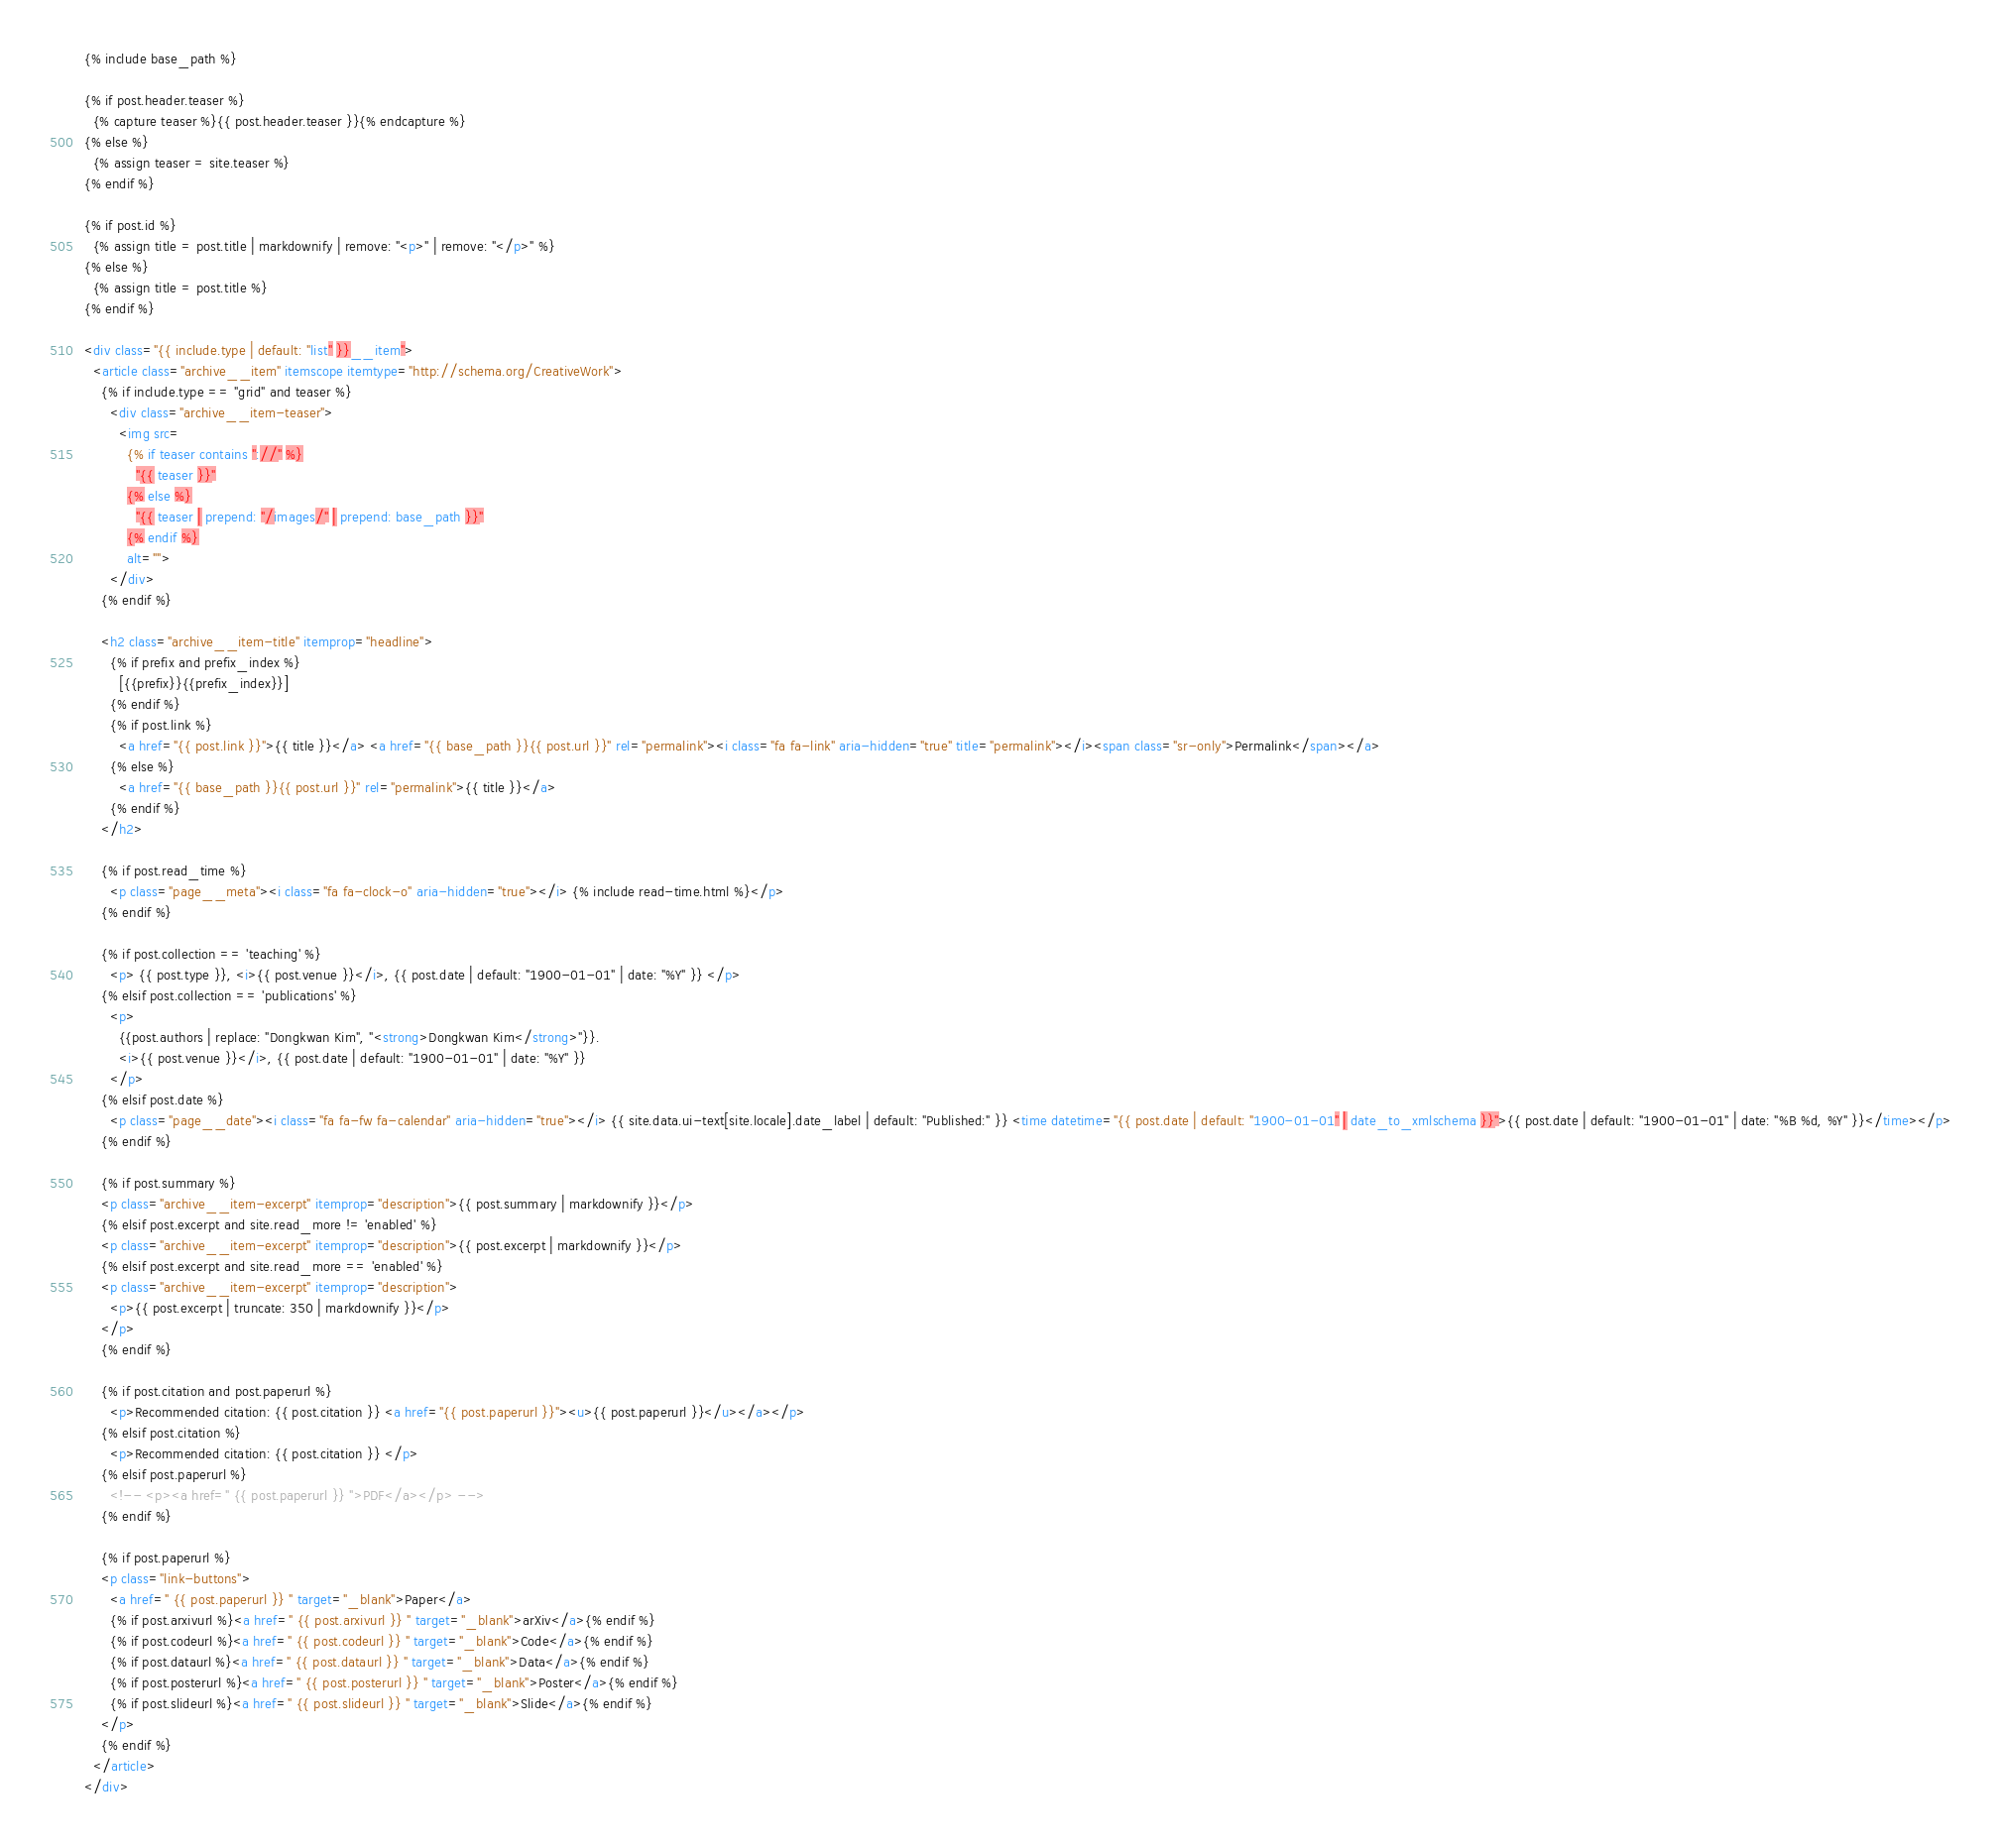<code> <loc_0><loc_0><loc_500><loc_500><_HTML_>{% include base_path %}

{% if post.header.teaser %}
  {% capture teaser %}{{ post.header.teaser }}{% endcapture %}
{% else %}
  {% assign teaser = site.teaser %}
{% endif %}

{% if post.id %}
  {% assign title = post.title | markdownify | remove: "<p>" | remove: "</p>" %}
{% else %}
  {% assign title = post.title %}
{% endif %}

<div class="{{ include.type | default: "list" }}__item">
  <article class="archive__item" itemscope itemtype="http://schema.org/CreativeWork">
    {% if include.type == "grid" and teaser %}
      <div class="archive__item-teaser">
        <img src=
          {% if teaser contains "://" %}
            "{{ teaser }}"
          {% else %}
            "{{ teaser | prepend: "/images/" | prepend: base_path }}"
          {% endif %}
          alt="">
      </div>
    {% endif %}

    <h2 class="archive__item-title" itemprop="headline">
      {% if prefix and prefix_index %}
        [{{prefix}}{{prefix_index}}]
      {% endif %}
      {% if post.link %}
        <a href="{{ post.link }}">{{ title }}</a> <a href="{{ base_path }}{{ post.url }}" rel="permalink"><i class="fa fa-link" aria-hidden="true" title="permalink"></i><span class="sr-only">Permalink</span></a>
      {% else %}
        <a href="{{ base_path }}{{ post.url }}" rel="permalink">{{ title }}</a>
      {% endif %}
    </h2>
    
    {% if post.read_time %}
      <p class="page__meta"><i class="fa fa-clock-o" aria-hidden="true"></i> {% include read-time.html %}</p>
    {% endif %}

    {% if post.collection == 'teaching' %}
      <p> {{ post.type }}, <i>{{ post.venue }}</i>, {{ post.date | default: "1900-01-01" | date: "%Y" }} </p>
    {% elsif post.collection == 'publications' %}
      <p>
        {{post.authors | replace: "Dongkwan Kim", "<strong>Dongkwan Kim</strong>"}}.
        <i>{{ post.venue }}</i>, {{ post.date | default: "1900-01-01" | date: "%Y" }}
      </p>
    {% elsif post.date %}
      <p class="page__date"><i class="fa fa-fw fa-calendar" aria-hidden="true"></i> {{ site.data.ui-text[site.locale].date_label | default: "Published:" }} <time datetime="{{ post.date | default: "1900-01-01" | date_to_xmlschema }}">{{ post.date | default: "1900-01-01" | date: "%B %d, %Y" }}</time></p>
    {% endif %}

    {% if post.summary %}
    <p class="archive__item-excerpt" itemprop="description">{{ post.summary | markdownify }}</p>
    {% elsif post.excerpt and site.read_more != 'enabled' %}
    <p class="archive__item-excerpt" itemprop="description">{{ post.excerpt | markdownify }}</p>
    {% elsif post.excerpt and site.read_more == 'enabled' %}
    <p class="archive__item-excerpt" itemprop="description">
      <p>{{ post.excerpt | truncate: 350 | markdownify }}</p>
    </p>
    {% endif %}
    
    {% if post.citation and post.paperurl %}
      <p>Recommended citation: {{ post.citation }} <a href="{{ post.paperurl }}"><u>{{ post.paperurl }}</u></a></p>
    {% elsif post.citation %}
      <p>Recommended citation: {{ post.citation }} </p>
    {% elsif post.paperurl %}
      <!-- <p><a href=" {{ post.paperurl }} ">PDF</a></p> -->
    {% endif %}

    {% if post.paperurl %}
    <p class="link-buttons">
      <a href=" {{ post.paperurl }} " target="_blank">Paper</a>
      {% if post.arxivurl %}<a href=" {{ post.arxivurl }} " target="_blank">arXiv</a>{% endif %}
      {% if post.codeurl %}<a href=" {{ post.codeurl }} " target="_blank">Code</a>{% endif %}
      {% if post.dataurl %}<a href=" {{ post.dataurl }} " target="_blank">Data</a>{% endif %}
      {% if post.posterurl %}<a href=" {{ post.posterurl }} " target="_blank">Poster</a>{% endif %}
      {% if post.slideurl %}<a href=" {{ post.slideurl }} " target="_blank">Slide</a>{% endif %}
    </p>
    {% endif %}
  </article>
</div>
</code> 